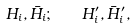<formula> <loc_0><loc_0><loc_500><loc_500>H _ { i } , \bar { H _ { i } } ; \quad H ^ { \prime } _ { i } , \bar { H } ^ { \prime } _ { i } ,</formula> 